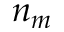<formula> <loc_0><loc_0><loc_500><loc_500>n _ { m }</formula> 